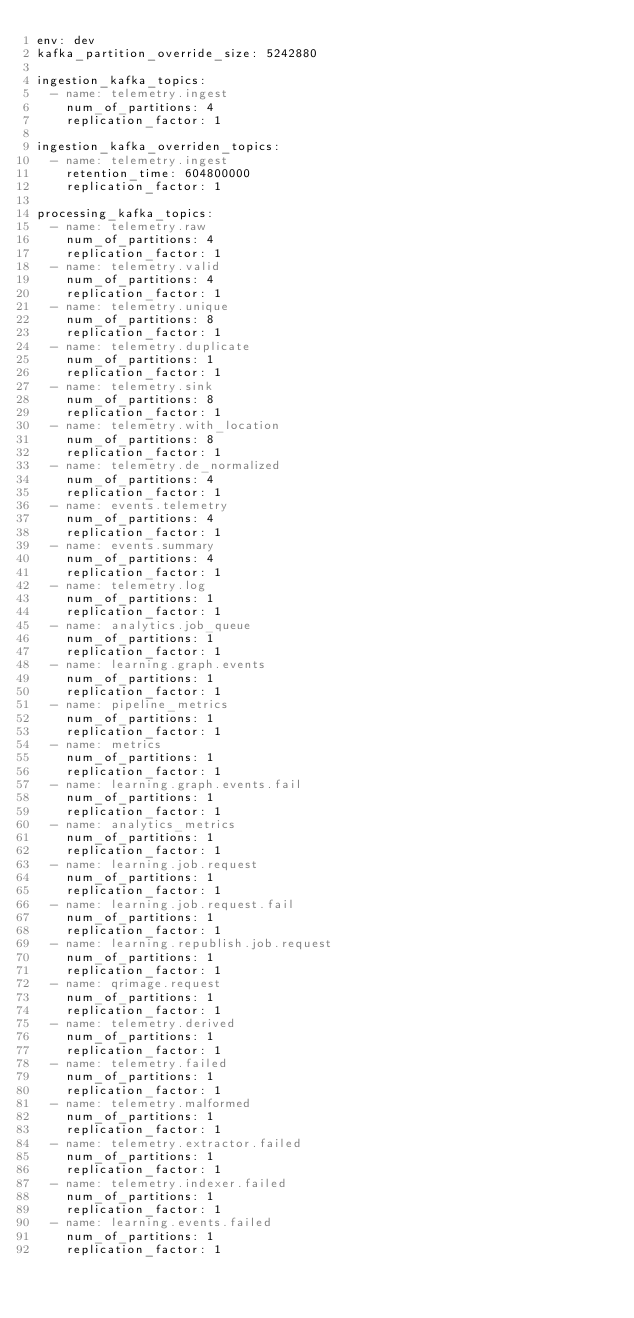<code> <loc_0><loc_0><loc_500><loc_500><_YAML_>env: dev
kafka_partition_override_size: 5242880

ingestion_kafka_topics:
  - name: telemetry.ingest
    num_of_partitions: 4
    replication_factor: 1

ingestion_kafka_overriden_topics:
  - name: telemetry.ingest
    retention_time: 604800000
    replication_factor: 1

processing_kafka_topics:
  - name: telemetry.raw
    num_of_partitions: 4
    replication_factor: 1
  - name: telemetry.valid
    num_of_partitions: 4
    replication_factor: 1
  - name: telemetry.unique
    num_of_partitions: 8
    replication_factor: 1
  - name: telemetry.duplicate
    num_of_partitions: 1
    replication_factor: 1
  - name: telemetry.sink
    num_of_partitions: 8
    replication_factor: 1
  - name: telemetry.with_location
    num_of_partitions: 8
    replication_factor: 1
  - name: telemetry.de_normalized
    num_of_partitions: 4
    replication_factor: 1
  - name: events.telemetry
    num_of_partitions: 4
    replication_factor: 1
  - name: events.summary
    num_of_partitions: 4
    replication_factor: 1
  - name: telemetry.log
    num_of_partitions: 1
    replication_factor: 1
  - name: analytics.job_queue
    num_of_partitions: 1
    replication_factor: 1
  - name: learning.graph.events
    num_of_partitions: 1
    replication_factor: 1
  - name: pipeline_metrics
    num_of_partitions: 1
    replication_factor: 1
  - name: metrics
    num_of_partitions: 1
    replication_factor: 1
  - name: learning.graph.events.fail
    num_of_partitions: 1
    replication_factor: 1
  - name: analytics_metrics
    num_of_partitions: 1
    replication_factor: 1
  - name: learning.job.request 
    num_of_partitions: 1
    replication_factor: 1
  - name: learning.job.request.fail
    num_of_partitions: 1
    replication_factor: 1
  - name: learning.republish.job.request
    num_of_partitions: 1
    replication_factor: 1
  - name: qrimage.request
    num_of_partitions: 1
    replication_factor: 1
  - name: telemetry.derived
    num_of_partitions: 1
    replication_factor: 1
  - name: telemetry.failed
    num_of_partitions: 1
    replication_factor: 1
  - name: telemetry.malformed
    num_of_partitions: 1
    replication_factor: 1
  - name: telemetry.extractor.failed
    num_of_partitions: 1
    replication_factor: 1
  - name: telemetry.indexer.failed
    num_of_partitions: 1
    replication_factor: 1
  - name: learning.events.failed
    num_of_partitions: 1
    replication_factor: 1
</code> 